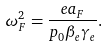<formula> <loc_0><loc_0><loc_500><loc_500>\omega _ { F } ^ { 2 } = { \frac { e a _ { F } } { p _ { 0 } \beta _ { e } \gamma _ { e } } } .</formula> 